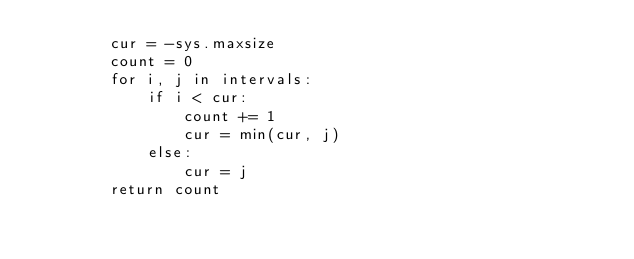Convert code to text. <code><loc_0><loc_0><loc_500><loc_500><_Python_>        cur = -sys.maxsize
        count = 0
        for i, j in intervals:
            if i < cur:
                count += 1
                cur = min(cur, j)
            else:
                cur = j
        return count
        </code> 